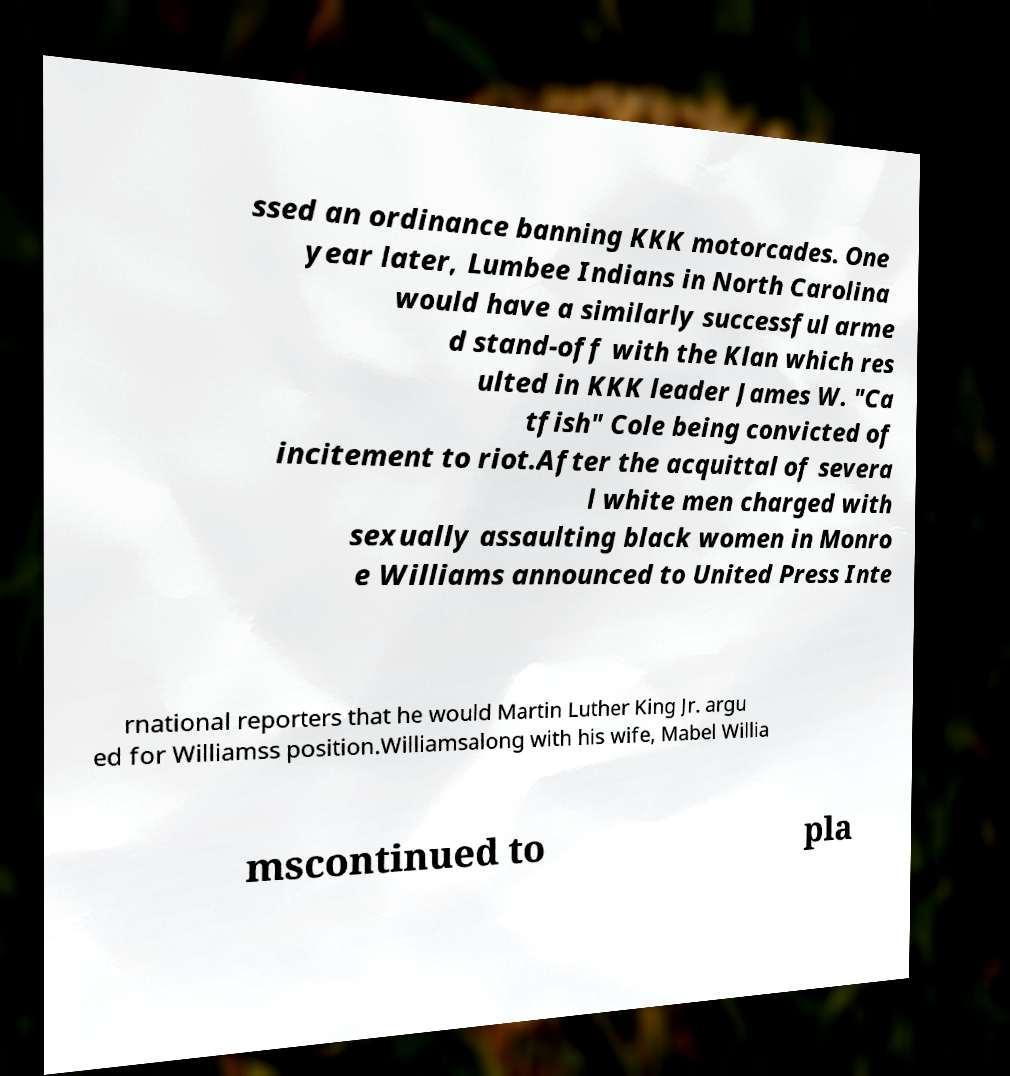Please identify and transcribe the text found in this image. ssed an ordinance banning KKK motorcades. One year later, Lumbee Indians in North Carolina would have a similarly successful arme d stand-off with the Klan which res ulted in KKK leader James W. "Ca tfish" Cole being convicted of incitement to riot.After the acquittal of severa l white men charged with sexually assaulting black women in Monro e Williams announced to United Press Inte rnational reporters that he would Martin Luther King Jr. argu ed for Williamss position.Williamsalong with his wife, Mabel Willia mscontinued to pla 